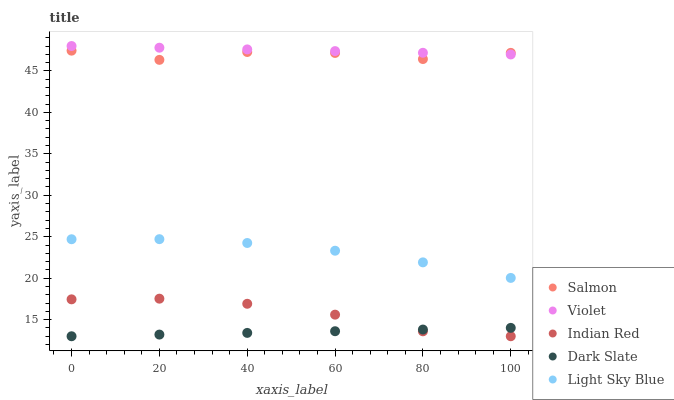Does Dark Slate have the minimum area under the curve?
Answer yes or no. Yes. Does Violet have the maximum area under the curve?
Answer yes or no. Yes. Does Light Sky Blue have the minimum area under the curve?
Answer yes or no. No. Does Light Sky Blue have the maximum area under the curve?
Answer yes or no. No. Is Dark Slate the smoothest?
Answer yes or no. Yes. Is Salmon the roughest?
Answer yes or no. Yes. Is Light Sky Blue the smoothest?
Answer yes or no. No. Is Light Sky Blue the roughest?
Answer yes or no. No. Does Dark Slate have the lowest value?
Answer yes or no. Yes. Does Light Sky Blue have the lowest value?
Answer yes or no. No. Does Violet have the highest value?
Answer yes or no. Yes. Does Light Sky Blue have the highest value?
Answer yes or no. No. Is Indian Red less than Violet?
Answer yes or no. Yes. Is Violet greater than Light Sky Blue?
Answer yes or no. Yes. Does Dark Slate intersect Indian Red?
Answer yes or no. Yes. Is Dark Slate less than Indian Red?
Answer yes or no. No. Is Dark Slate greater than Indian Red?
Answer yes or no. No. Does Indian Red intersect Violet?
Answer yes or no. No. 